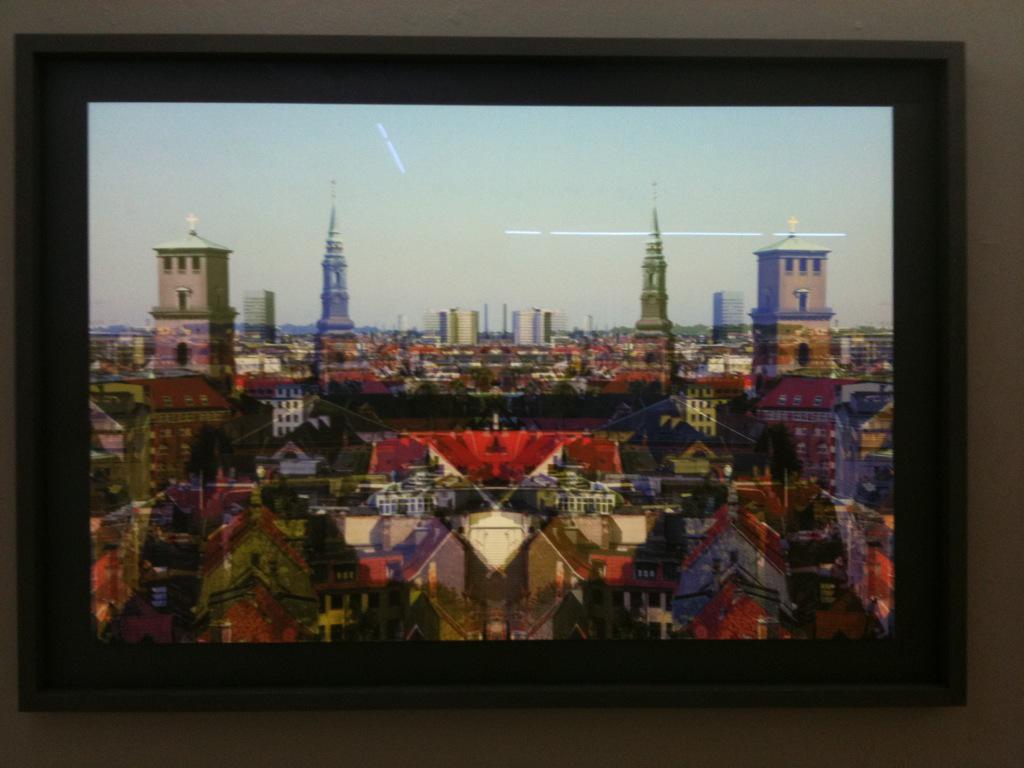Could you give a brief overview of what you see in this image? In the image we can see the photo frame, in the photo frame we can see the buildings and the sky. 